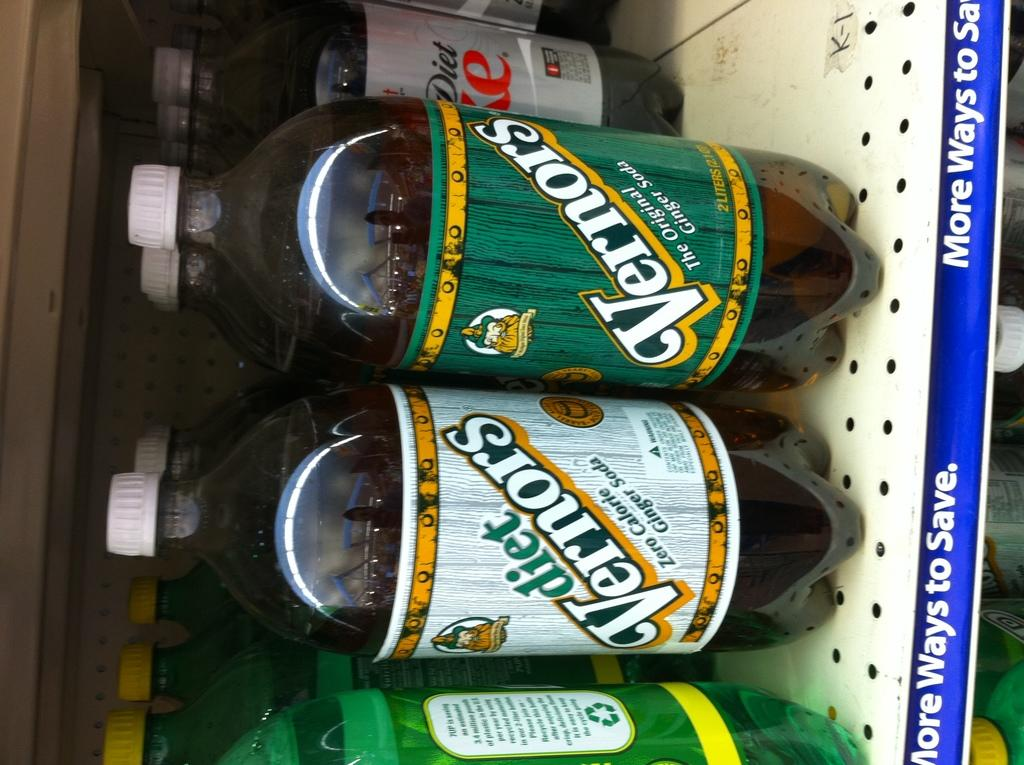<image>
Render a clear and concise summary of the photo. Diet Vernors is on the shelf for sale at a store. 